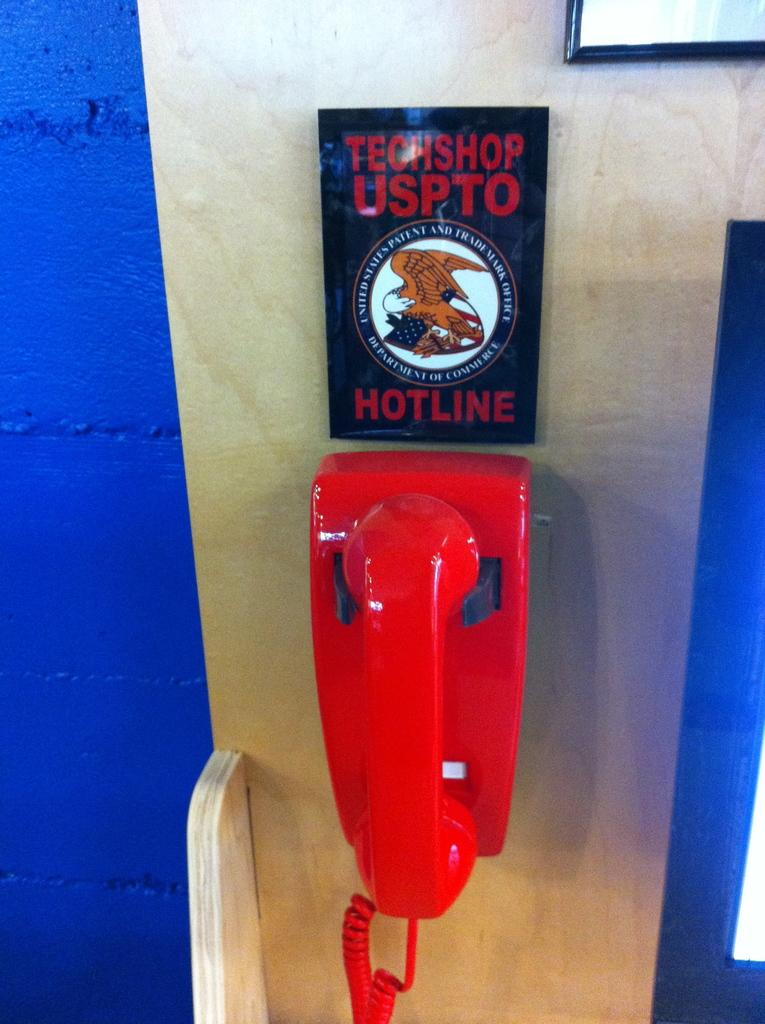<image>
Render a clear and concise summary of the photo. A red corded telephone hangs on a wall beneath a sign that says Techshop USPTO Hotline. 